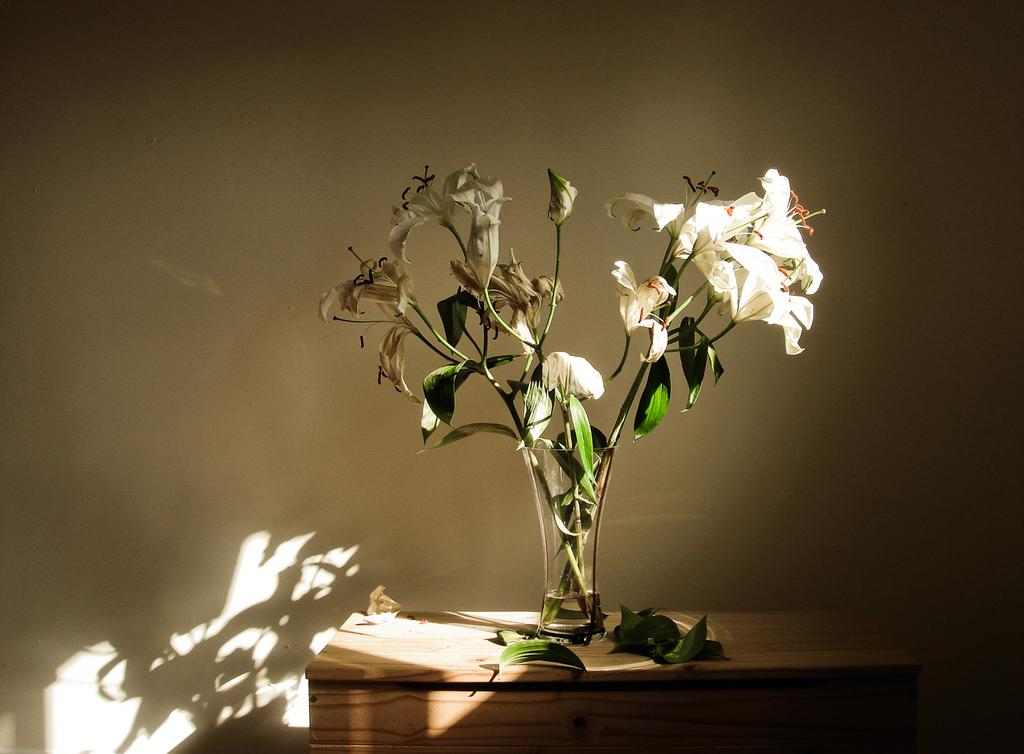What is on the table in the image? There are flowers in a vase and leaves on the table. Can you describe the flowers in the vase? The flowers are in a vase on the table. What else is present on the table besides the flowers? There are leaves on the table. What type of country can be seen in the background of the image? There is no country visible in the image; it only shows flowers in a vase and leaves on a table. How many fields are present in the image? There are no fields present in the image; it only shows flowers in a vase and leaves on a table. 